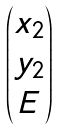<formula> <loc_0><loc_0><loc_500><loc_500>\begin{pmatrix} x _ { 2 } \\ y _ { 2 } \\ E \end{pmatrix}</formula> 